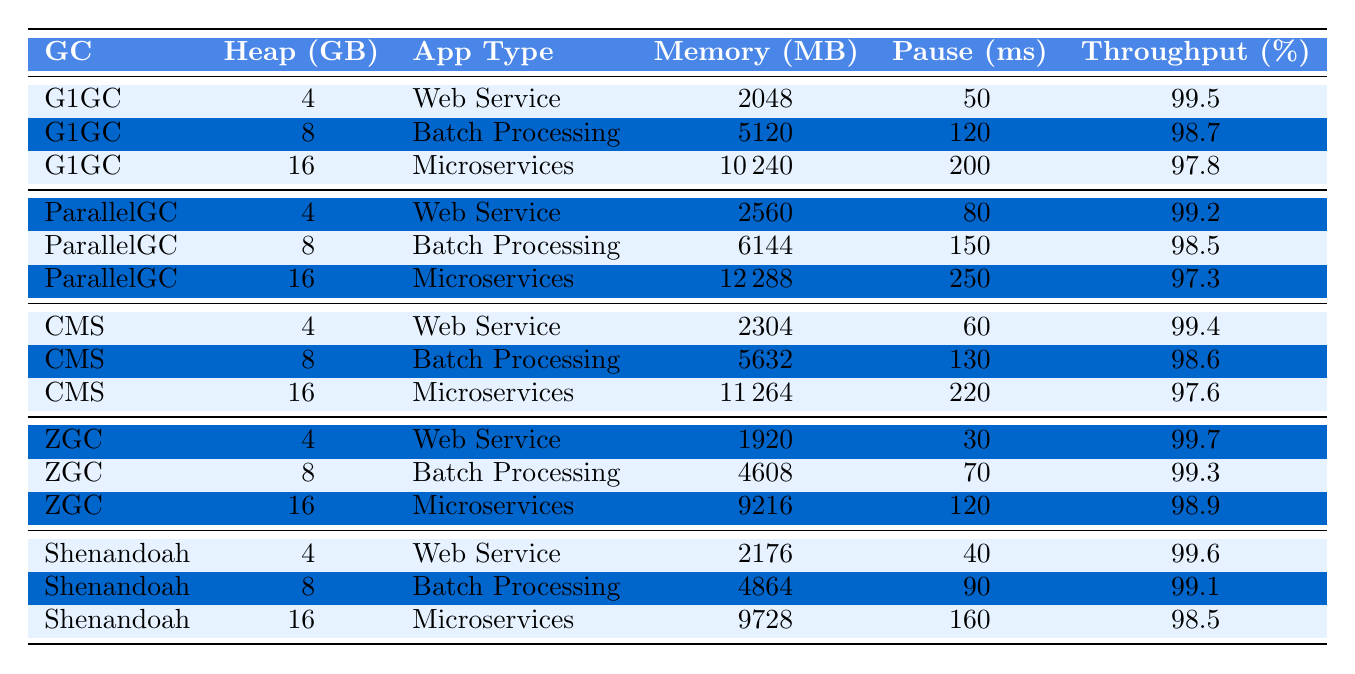What is the memory usage for the G1GC garbage collector with a heap size of 8 GB? In the table, we look under the row for G1GC where the heap size is listed as 8 GB. The corresponding memory usage is 5120 MB.
Answer: 5120 MB Which garbage collector has the lowest GC pause time for a 4 GB heap size? By examining the 4 GB entries, we can see the GC pause times: G1GC has 50 ms, ParallelGC has 80 ms, CMS has 60 ms, ZGC has 30 ms, and Shenandoah has 40 ms. The lowest is ZGC with 30 ms.
Answer: ZGC What is the average memory usage for the Microservices application type across all garbage collectors? The memory usages for Microservices are 10240 MB (G1GC), 12288 MB (ParallelGC), 11264 MB (CMS), 9216 MB (ZGC), and 9728 MB (Shenandoah). Summing these gives us: 10240 + 12288 + 11264 + 9216 + 9728 = 52016 MB. Dividing by the number of entries (5) gives an average of 10403.2 MB.
Answer: 10403.2 MB Is the throughput for G1GC in Batch Processing higher than that of ParallelGC in Microservices? G1GC for Batch Processing shows a throughput of 98.7%, while ParallelGC in Microservices shows a throughput of 97.3%. Since 98.7% is greater than 97.3%, the statement is true.
Answer: Yes How does the GC pause time for Shenandoah in Batch Processing compare to the pause time for CMS in the same application type? Looking at the Batch Processing data, Shenandoah has a pause time of 90 ms, while CMS has a pause time of 130 ms. Since 90 ms is less than 130 ms, Shenandoah has a shorter pause time.
Answer: Shenandoah has a shorter pause time What is the total memory usage for all garbage collectors at a 16 GB heap size? We sum the memory usage values for the 16 GB entries: 10240 MB (G1GC) + 12288 MB (ParallelGC) + 11264 MB (CMS) + 9216 MB (ZGC) + 9728 MB (Shenandoah) = 52016 MB.
Answer: 52016 MB Which garbage collector shows the highest throughput for Web Service applications? The throughput values for Web Service applications are: G1GC (99.5%), ParallelGC (99.2%), CMS (99.4%), ZGC (99.7%), and Shenandoah (99.6%). The highest throughput is from ZGC at 99.7%.
Answer: ZGC Calculate the difference in memory usage between the highest and lowest memory usage for the Microservices application type. For Microservices, the memory usages are 10240 MB (G1GC), 12288 MB (ParallelGC), 11264 MB (CMS), 9216 MB (ZGC), and 9728 MB (Shenandoah). The highest is 12288 MB, and the lowest is 9216 MB. The difference is 12288 - 9216 = 3072 MB.
Answer: 3072 MB Does the ParallelGC have a higher memory usage than G1GC for 8 GB of heap size? For 8 GB, G1GC has a memory usage of 5120 MB, whereas ParallelGC has 6144 MB. Since 6144 is greater than 5120, the statement is true.
Answer: Yes What is the average GC pause time for all the garbage collectors at a 16 GB heap size? The pause times for 16 GB are: 200 ms (G1GC), 250 ms (ParallelGC), 220 ms (CMS), 120 ms (ZGC), and 160 ms (Shenandoah). Summing gives 200 + 250 + 220 + 120 + 160 = 950 ms. The average pause time is 950 ms / 5 = 190 ms.
Answer: 190 ms Which application type generally uses more memory, Web Service or Batch Processing, across all garbage collectors? In the table, we look at memory usage for each collector type. For Web Service, the usages are 2048 MB for G1GC, 2560 MB for ParallelGC, 2304 MB for CMS, 1920 MB for ZGC, and 2176 MB for Shenandoah, summing to 11168 MB. For Batch Processing, the usages are 5120 MB (G1GC), 6144 MB (ParallelGC), 5632 MB (CMS), 4608 MB (ZGC), and 4864 MB (Shenandoah), summing to 26468 MB. Compared, Batch Processing uses more memory than Web Service.
Answer: Batch Processing uses more memory 